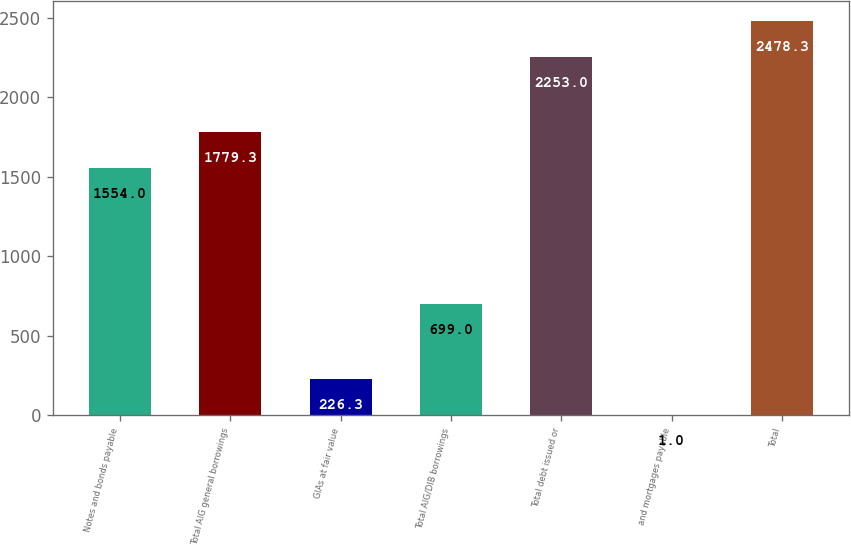<chart> <loc_0><loc_0><loc_500><loc_500><bar_chart><fcel>Notes and bonds payable<fcel>Total AIG general borrowings<fcel>GIAs at fair value<fcel>Total AIG/DIB borrowings<fcel>Total debt issued or<fcel>and mortgages payable<fcel>Total<nl><fcel>1554<fcel>1779.3<fcel>226.3<fcel>699<fcel>2253<fcel>1<fcel>2478.3<nl></chart> 